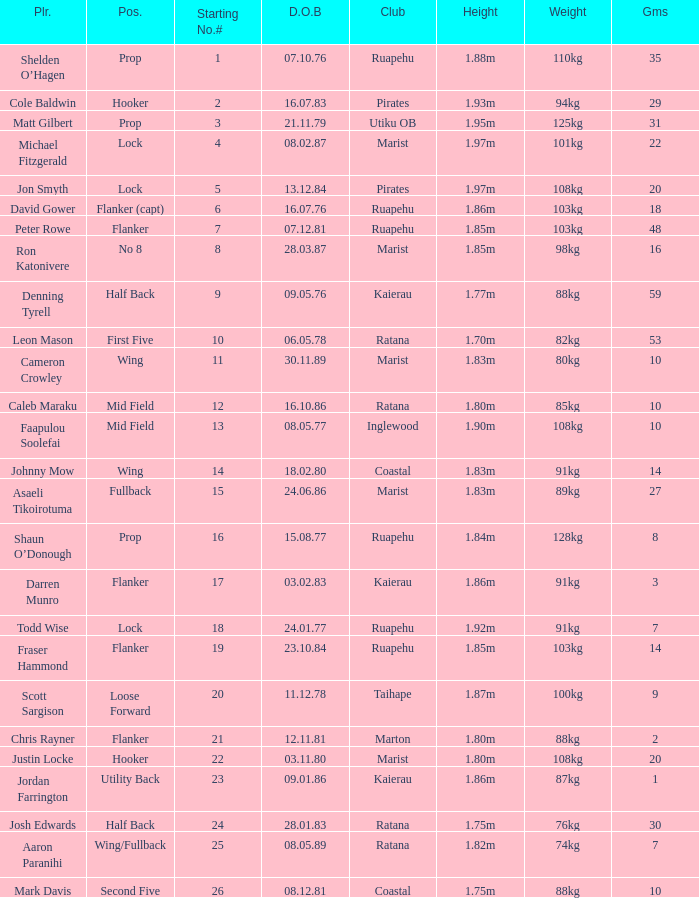What is the date of birth for the player in the Inglewood club? 80577.0. 